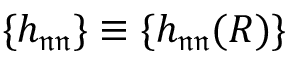Convert formula to latex. <formula><loc_0><loc_0><loc_500><loc_500>\{ h _ { \mathfrak { n } \mathfrak { n } } \} \equiv \{ h _ { \mathfrak { n } \mathfrak { n } } ( R ) \}</formula> 